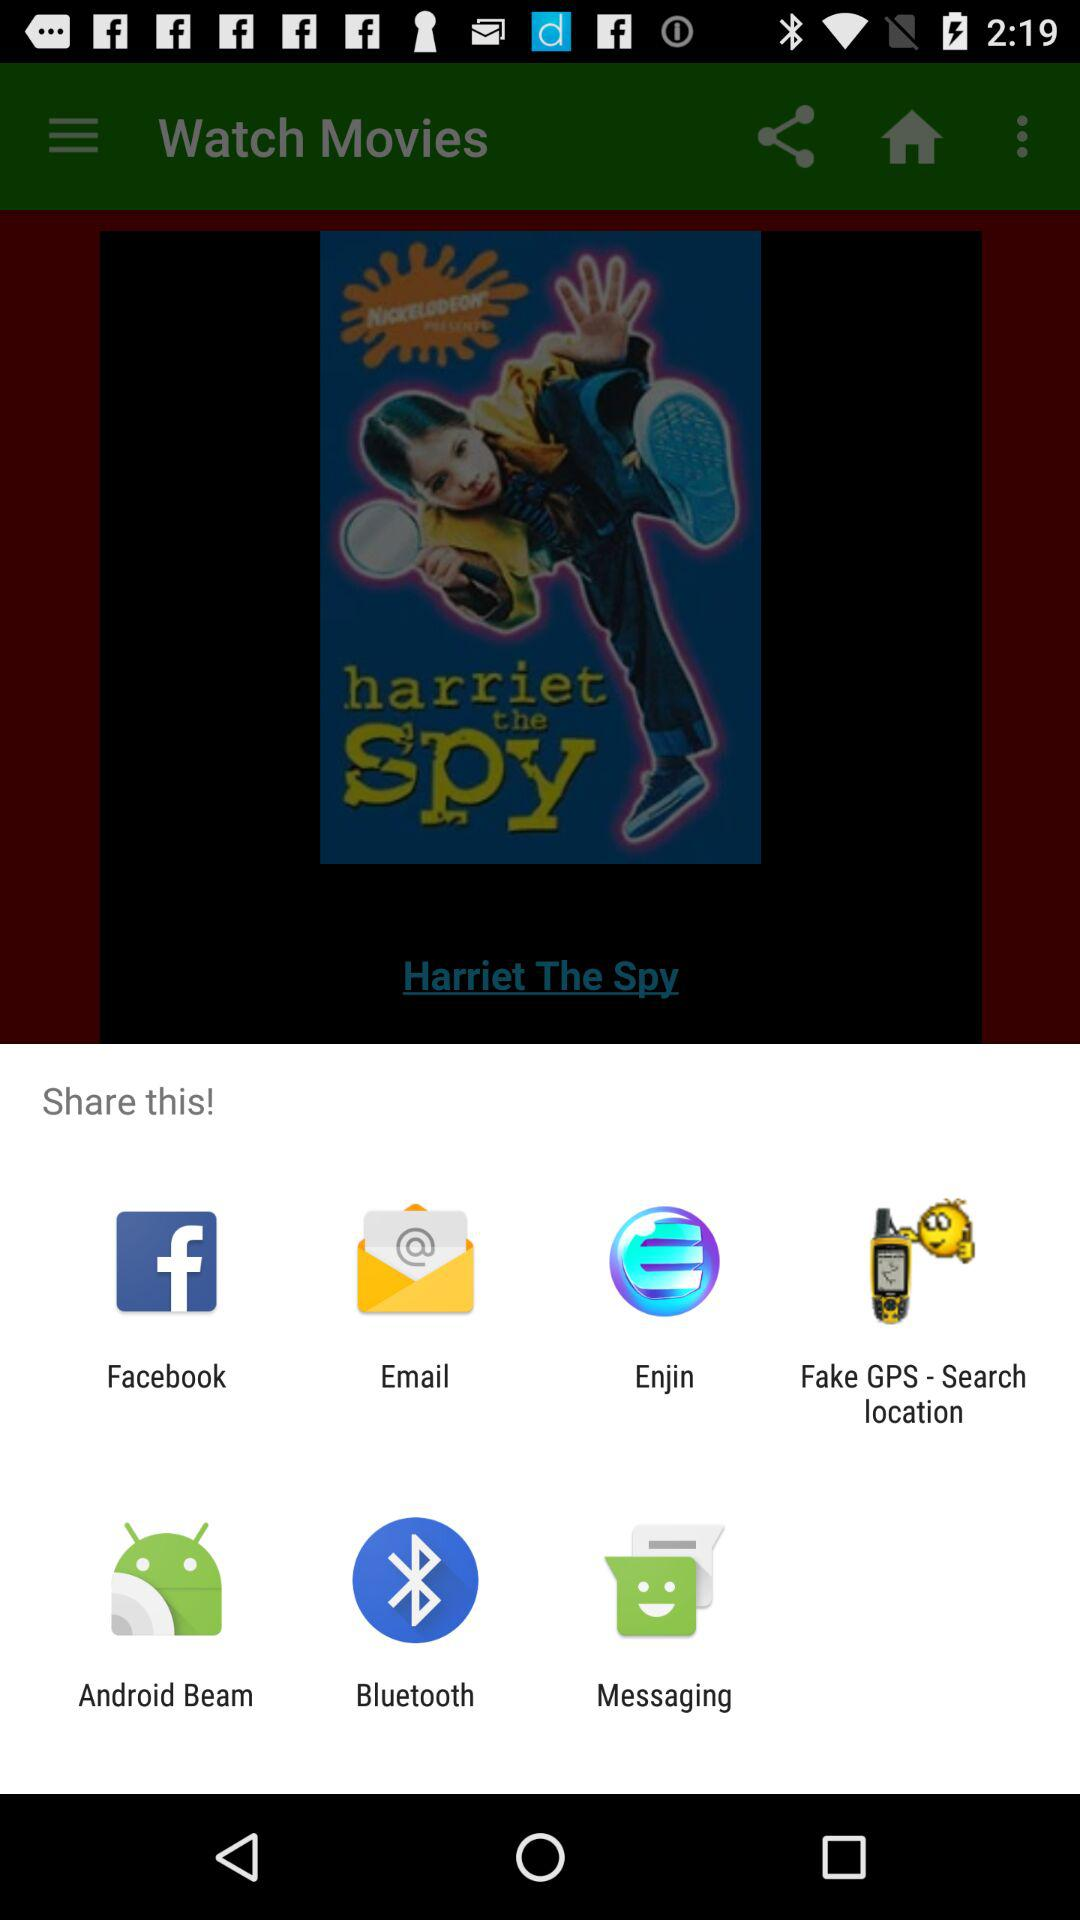Through what applications can we share the movies? You can share with "Facebook", "Email", "Enjin", "Fake GPS - Search location", "Android Beam ", "Bluetooth", and " Messaging". 